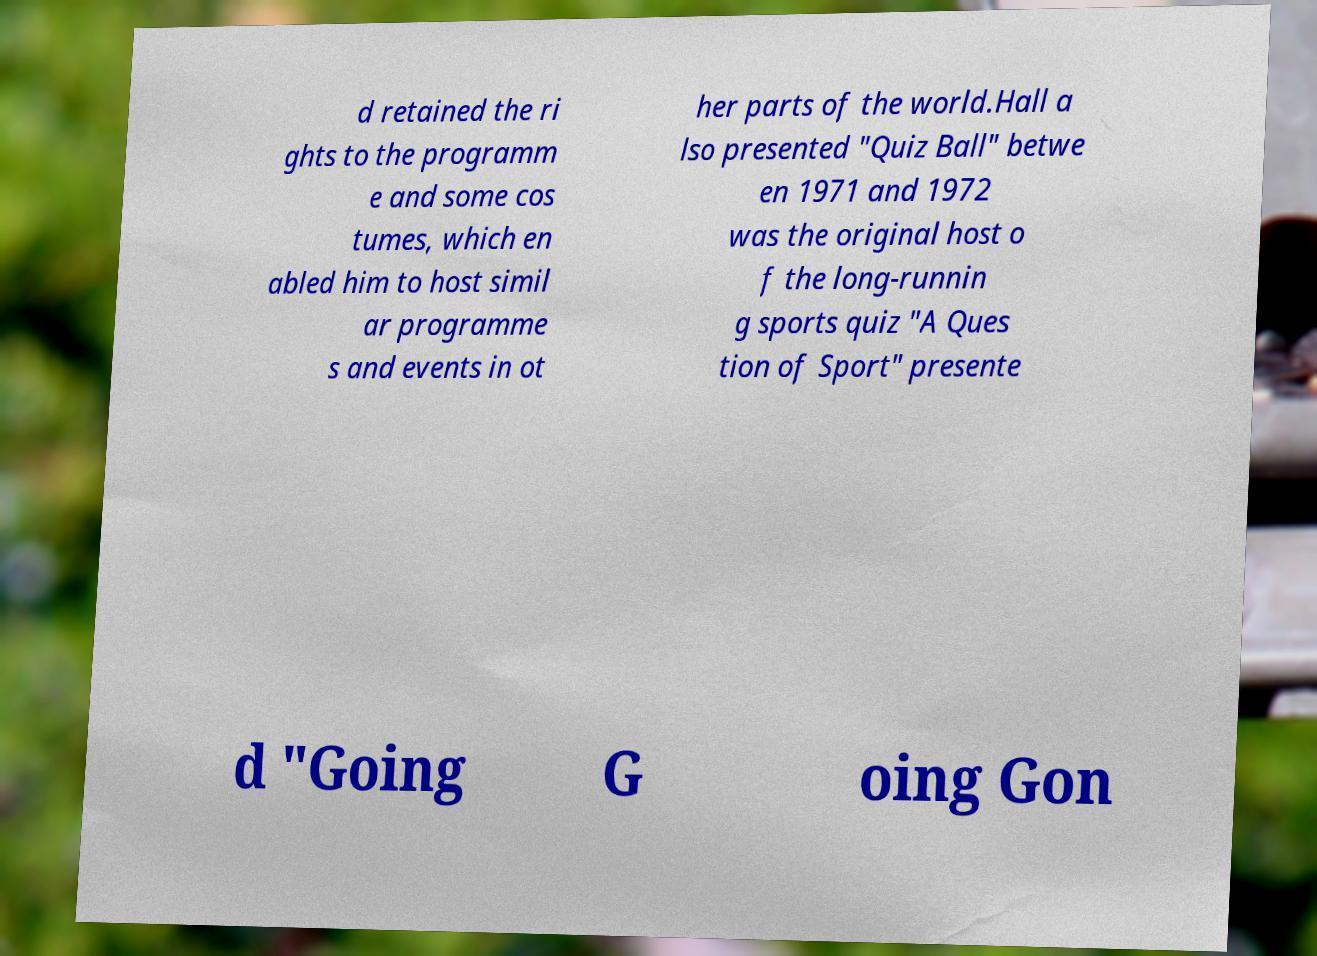Please read and relay the text visible in this image. What does it say? d retained the ri ghts to the programm e and some cos tumes, which en abled him to host simil ar programme s and events in ot her parts of the world.Hall a lso presented "Quiz Ball" betwe en 1971 and 1972 was the original host o f the long-runnin g sports quiz "A Ques tion of Sport" presente d "Going G oing Gon 